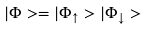<formula> <loc_0><loc_0><loc_500><loc_500>| \Phi > = | \Phi _ { \uparrow } > | \Phi _ { \downarrow } ></formula> 